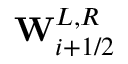Convert formula to latex. <formula><loc_0><loc_0><loc_500><loc_500>W _ { i + 1 / 2 } ^ { L , R }</formula> 